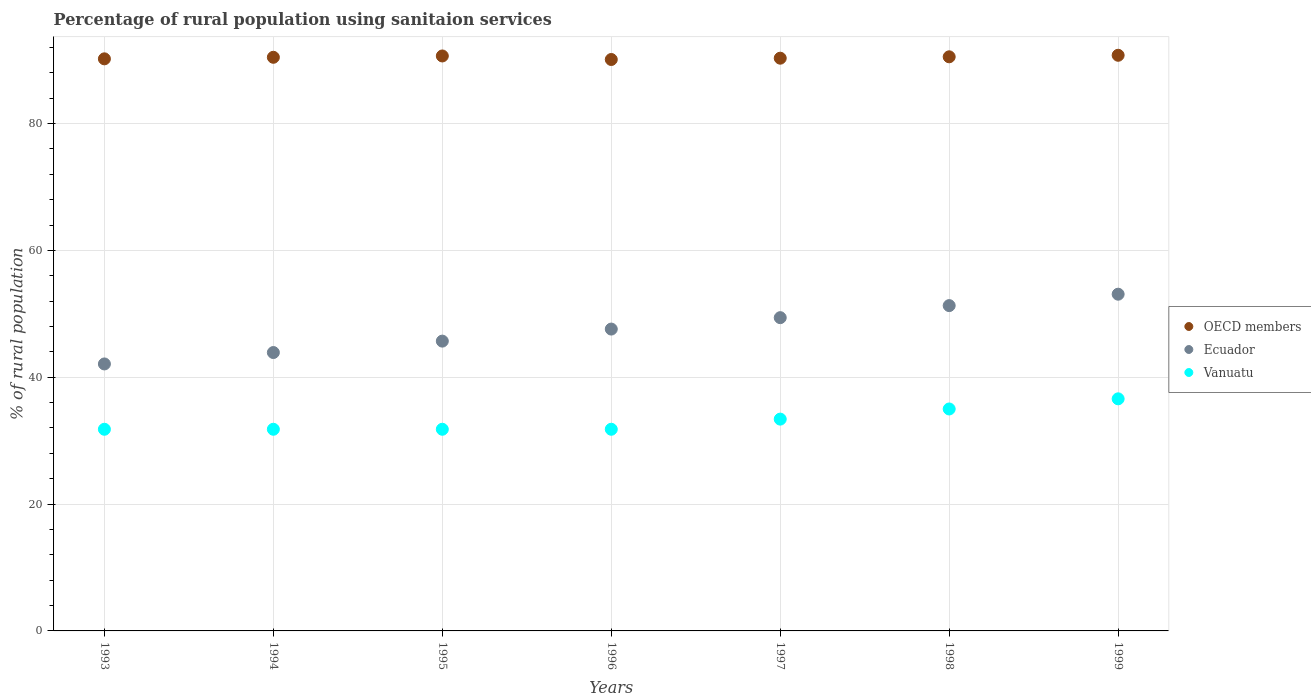How many different coloured dotlines are there?
Offer a very short reply. 3. Is the number of dotlines equal to the number of legend labels?
Give a very brief answer. Yes. What is the percentage of rural population using sanitaion services in Ecuador in 1999?
Offer a very short reply. 53.1. Across all years, what is the maximum percentage of rural population using sanitaion services in Vanuatu?
Your answer should be compact. 36.6. Across all years, what is the minimum percentage of rural population using sanitaion services in Vanuatu?
Your response must be concise. 31.8. In which year was the percentage of rural population using sanitaion services in Ecuador minimum?
Make the answer very short. 1993. What is the total percentage of rural population using sanitaion services in OECD members in the graph?
Offer a terse response. 633.08. What is the difference between the percentage of rural population using sanitaion services in OECD members in 1993 and that in 1999?
Your response must be concise. -0.56. What is the difference between the percentage of rural population using sanitaion services in Vanuatu in 1993 and the percentage of rural population using sanitaion services in Ecuador in 1997?
Ensure brevity in your answer.  -17.6. What is the average percentage of rural population using sanitaion services in Vanuatu per year?
Your answer should be very brief. 33.17. In the year 1998, what is the difference between the percentage of rural population using sanitaion services in Vanuatu and percentage of rural population using sanitaion services in Ecuador?
Your answer should be very brief. -16.3. In how many years, is the percentage of rural population using sanitaion services in OECD members greater than 80 %?
Ensure brevity in your answer.  7. Is the difference between the percentage of rural population using sanitaion services in Vanuatu in 1994 and 1999 greater than the difference between the percentage of rural population using sanitaion services in Ecuador in 1994 and 1999?
Keep it short and to the point. Yes. What is the difference between the highest and the second highest percentage of rural population using sanitaion services in Vanuatu?
Keep it short and to the point. 1.6. What is the difference between the highest and the lowest percentage of rural population using sanitaion services in OECD members?
Your answer should be very brief. 0.67. Is the sum of the percentage of rural population using sanitaion services in Ecuador in 1993 and 1996 greater than the maximum percentage of rural population using sanitaion services in OECD members across all years?
Your answer should be compact. No. Does the percentage of rural population using sanitaion services in Vanuatu monotonically increase over the years?
Provide a succinct answer. No. Is the percentage of rural population using sanitaion services in OECD members strictly greater than the percentage of rural population using sanitaion services in Ecuador over the years?
Your answer should be very brief. Yes. How many dotlines are there?
Your answer should be very brief. 3. What is the difference between two consecutive major ticks on the Y-axis?
Give a very brief answer. 20. Does the graph contain grids?
Make the answer very short. Yes. How many legend labels are there?
Your response must be concise. 3. What is the title of the graph?
Offer a very short reply. Percentage of rural population using sanitaion services. Does "Azerbaijan" appear as one of the legend labels in the graph?
Give a very brief answer. No. What is the label or title of the X-axis?
Your response must be concise. Years. What is the label or title of the Y-axis?
Offer a very short reply. % of rural population. What is the % of rural population in OECD members in 1993?
Offer a very short reply. 90.21. What is the % of rural population in Ecuador in 1993?
Offer a terse response. 42.1. What is the % of rural population in Vanuatu in 1993?
Provide a short and direct response. 31.8. What is the % of rural population in OECD members in 1994?
Your response must be concise. 90.46. What is the % of rural population of Ecuador in 1994?
Your response must be concise. 43.9. What is the % of rural population of Vanuatu in 1994?
Your answer should be compact. 31.8. What is the % of rural population in OECD members in 1995?
Provide a short and direct response. 90.67. What is the % of rural population of Ecuador in 1995?
Your response must be concise. 45.7. What is the % of rural population of Vanuatu in 1995?
Give a very brief answer. 31.8. What is the % of rural population of OECD members in 1996?
Ensure brevity in your answer.  90.11. What is the % of rural population in Ecuador in 1996?
Ensure brevity in your answer.  47.6. What is the % of rural population in Vanuatu in 1996?
Keep it short and to the point. 31.8. What is the % of rural population of OECD members in 1997?
Ensure brevity in your answer.  90.32. What is the % of rural population of Ecuador in 1997?
Make the answer very short. 49.4. What is the % of rural population in Vanuatu in 1997?
Your answer should be compact. 33.4. What is the % of rural population in OECD members in 1998?
Offer a terse response. 90.53. What is the % of rural population of Ecuador in 1998?
Provide a short and direct response. 51.3. What is the % of rural population of OECD members in 1999?
Keep it short and to the point. 90.78. What is the % of rural population of Ecuador in 1999?
Your answer should be compact. 53.1. What is the % of rural population in Vanuatu in 1999?
Your response must be concise. 36.6. Across all years, what is the maximum % of rural population of OECD members?
Provide a short and direct response. 90.78. Across all years, what is the maximum % of rural population in Ecuador?
Your answer should be very brief. 53.1. Across all years, what is the maximum % of rural population of Vanuatu?
Your response must be concise. 36.6. Across all years, what is the minimum % of rural population in OECD members?
Make the answer very short. 90.11. Across all years, what is the minimum % of rural population in Ecuador?
Ensure brevity in your answer.  42.1. Across all years, what is the minimum % of rural population in Vanuatu?
Provide a succinct answer. 31.8. What is the total % of rural population of OECD members in the graph?
Your answer should be compact. 633.08. What is the total % of rural population in Ecuador in the graph?
Provide a short and direct response. 333.1. What is the total % of rural population in Vanuatu in the graph?
Offer a very short reply. 232.2. What is the difference between the % of rural population of OECD members in 1993 and that in 1994?
Your answer should be compact. -0.24. What is the difference between the % of rural population in Ecuador in 1993 and that in 1994?
Give a very brief answer. -1.8. What is the difference between the % of rural population of OECD members in 1993 and that in 1995?
Offer a very short reply. -0.45. What is the difference between the % of rural population in OECD members in 1993 and that in 1996?
Your response must be concise. 0.1. What is the difference between the % of rural population of Vanuatu in 1993 and that in 1996?
Provide a short and direct response. 0. What is the difference between the % of rural population in OECD members in 1993 and that in 1997?
Make the answer very short. -0.1. What is the difference between the % of rural population in Ecuador in 1993 and that in 1997?
Offer a very short reply. -7.3. What is the difference between the % of rural population of OECD members in 1993 and that in 1998?
Your answer should be compact. -0.32. What is the difference between the % of rural population of Vanuatu in 1993 and that in 1998?
Your answer should be very brief. -3.2. What is the difference between the % of rural population in OECD members in 1993 and that in 1999?
Keep it short and to the point. -0.56. What is the difference between the % of rural population in Ecuador in 1993 and that in 1999?
Your answer should be compact. -11. What is the difference between the % of rural population in Vanuatu in 1993 and that in 1999?
Offer a very short reply. -4.8. What is the difference between the % of rural population of OECD members in 1994 and that in 1995?
Provide a succinct answer. -0.21. What is the difference between the % of rural population of Vanuatu in 1994 and that in 1995?
Provide a succinct answer. 0. What is the difference between the % of rural population in OECD members in 1994 and that in 1996?
Make the answer very short. 0.35. What is the difference between the % of rural population in Ecuador in 1994 and that in 1996?
Your answer should be very brief. -3.7. What is the difference between the % of rural population in Vanuatu in 1994 and that in 1996?
Offer a terse response. 0. What is the difference between the % of rural population of OECD members in 1994 and that in 1997?
Keep it short and to the point. 0.14. What is the difference between the % of rural population of Ecuador in 1994 and that in 1997?
Your answer should be compact. -5.5. What is the difference between the % of rural population of OECD members in 1994 and that in 1998?
Provide a succinct answer. -0.08. What is the difference between the % of rural population of Vanuatu in 1994 and that in 1998?
Give a very brief answer. -3.2. What is the difference between the % of rural population in OECD members in 1994 and that in 1999?
Provide a short and direct response. -0.32. What is the difference between the % of rural population of Ecuador in 1994 and that in 1999?
Provide a short and direct response. -9.2. What is the difference between the % of rural population in Vanuatu in 1994 and that in 1999?
Make the answer very short. -4.8. What is the difference between the % of rural population of OECD members in 1995 and that in 1996?
Provide a succinct answer. 0.56. What is the difference between the % of rural population in Vanuatu in 1995 and that in 1996?
Offer a terse response. 0. What is the difference between the % of rural population of OECD members in 1995 and that in 1997?
Offer a very short reply. 0.35. What is the difference between the % of rural population of OECD members in 1995 and that in 1998?
Give a very brief answer. 0.13. What is the difference between the % of rural population in Vanuatu in 1995 and that in 1998?
Provide a short and direct response. -3.2. What is the difference between the % of rural population of OECD members in 1995 and that in 1999?
Provide a succinct answer. -0.11. What is the difference between the % of rural population of OECD members in 1996 and that in 1997?
Your answer should be very brief. -0.21. What is the difference between the % of rural population of Ecuador in 1996 and that in 1997?
Your answer should be compact. -1.8. What is the difference between the % of rural population of Vanuatu in 1996 and that in 1997?
Offer a very short reply. -1.6. What is the difference between the % of rural population in OECD members in 1996 and that in 1998?
Offer a terse response. -0.42. What is the difference between the % of rural population of Ecuador in 1996 and that in 1998?
Give a very brief answer. -3.7. What is the difference between the % of rural population of Vanuatu in 1996 and that in 1998?
Offer a terse response. -3.2. What is the difference between the % of rural population of OECD members in 1996 and that in 1999?
Ensure brevity in your answer.  -0.67. What is the difference between the % of rural population of Vanuatu in 1996 and that in 1999?
Make the answer very short. -4.8. What is the difference between the % of rural population in OECD members in 1997 and that in 1998?
Offer a very short reply. -0.22. What is the difference between the % of rural population of Vanuatu in 1997 and that in 1998?
Offer a very short reply. -1.6. What is the difference between the % of rural population in OECD members in 1997 and that in 1999?
Ensure brevity in your answer.  -0.46. What is the difference between the % of rural population of Ecuador in 1997 and that in 1999?
Ensure brevity in your answer.  -3.7. What is the difference between the % of rural population in OECD members in 1998 and that in 1999?
Provide a short and direct response. -0.24. What is the difference between the % of rural population of OECD members in 1993 and the % of rural population of Ecuador in 1994?
Ensure brevity in your answer.  46.31. What is the difference between the % of rural population of OECD members in 1993 and the % of rural population of Vanuatu in 1994?
Ensure brevity in your answer.  58.41. What is the difference between the % of rural population of OECD members in 1993 and the % of rural population of Ecuador in 1995?
Provide a short and direct response. 44.51. What is the difference between the % of rural population in OECD members in 1993 and the % of rural population in Vanuatu in 1995?
Offer a very short reply. 58.41. What is the difference between the % of rural population of OECD members in 1993 and the % of rural population of Ecuador in 1996?
Make the answer very short. 42.61. What is the difference between the % of rural population of OECD members in 1993 and the % of rural population of Vanuatu in 1996?
Give a very brief answer. 58.41. What is the difference between the % of rural population in Ecuador in 1993 and the % of rural population in Vanuatu in 1996?
Offer a very short reply. 10.3. What is the difference between the % of rural population in OECD members in 1993 and the % of rural population in Ecuador in 1997?
Your answer should be compact. 40.81. What is the difference between the % of rural population in OECD members in 1993 and the % of rural population in Vanuatu in 1997?
Keep it short and to the point. 56.81. What is the difference between the % of rural population in OECD members in 1993 and the % of rural population in Ecuador in 1998?
Ensure brevity in your answer.  38.91. What is the difference between the % of rural population of OECD members in 1993 and the % of rural population of Vanuatu in 1998?
Your response must be concise. 55.21. What is the difference between the % of rural population of Ecuador in 1993 and the % of rural population of Vanuatu in 1998?
Keep it short and to the point. 7.1. What is the difference between the % of rural population in OECD members in 1993 and the % of rural population in Ecuador in 1999?
Your response must be concise. 37.11. What is the difference between the % of rural population of OECD members in 1993 and the % of rural population of Vanuatu in 1999?
Your answer should be very brief. 53.61. What is the difference between the % of rural population of OECD members in 1994 and the % of rural population of Ecuador in 1995?
Offer a terse response. 44.76. What is the difference between the % of rural population of OECD members in 1994 and the % of rural population of Vanuatu in 1995?
Your answer should be very brief. 58.66. What is the difference between the % of rural population of Ecuador in 1994 and the % of rural population of Vanuatu in 1995?
Give a very brief answer. 12.1. What is the difference between the % of rural population of OECD members in 1994 and the % of rural population of Ecuador in 1996?
Ensure brevity in your answer.  42.86. What is the difference between the % of rural population of OECD members in 1994 and the % of rural population of Vanuatu in 1996?
Offer a very short reply. 58.66. What is the difference between the % of rural population of Ecuador in 1994 and the % of rural population of Vanuatu in 1996?
Provide a short and direct response. 12.1. What is the difference between the % of rural population in OECD members in 1994 and the % of rural population in Ecuador in 1997?
Your answer should be compact. 41.06. What is the difference between the % of rural population in OECD members in 1994 and the % of rural population in Vanuatu in 1997?
Give a very brief answer. 57.06. What is the difference between the % of rural population of Ecuador in 1994 and the % of rural population of Vanuatu in 1997?
Your response must be concise. 10.5. What is the difference between the % of rural population of OECD members in 1994 and the % of rural population of Ecuador in 1998?
Make the answer very short. 39.16. What is the difference between the % of rural population of OECD members in 1994 and the % of rural population of Vanuatu in 1998?
Provide a succinct answer. 55.46. What is the difference between the % of rural population in OECD members in 1994 and the % of rural population in Ecuador in 1999?
Provide a succinct answer. 37.36. What is the difference between the % of rural population of OECD members in 1994 and the % of rural population of Vanuatu in 1999?
Make the answer very short. 53.86. What is the difference between the % of rural population of Ecuador in 1994 and the % of rural population of Vanuatu in 1999?
Keep it short and to the point. 7.3. What is the difference between the % of rural population in OECD members in 1995 and the % of rural population in Ecuador in 1996?
Make the answer very short. 43.07. What is the difference between the % of rural population of OECD members in 1995 and the % of rural population of Vanuatu in 1996?
Give a very brief answer. 58.87. What is the difference between the % of rural population of Ecuador in 1995 and the % of rural population of Vanuatu in 1996?
Provide a succinct answer. 13.9. What is the difference between the % of rural population of OECD members in 1995 and the % of rural population of Ecuador in 1997?
Make the answer very short. 41.27. What is the difference between the % of rural population in OECD members in 1995 and the % of rural population in Vanuatu in 1997?
Offer a terse response. 57.27. What is the difference between the % of rural population of OECD members in 1995 and the % of rural population of Ecuador in 1998?
Offer a terse response. 39.37. What is the difference between the % of rural population in OECD members in 1995 and the % of rural population in Vanuatu in 1998?
Your response must be concise. 55.67. What is the difference between the % of rural population in Ecuador in 1995 and the % of rural population in Vanuatu in 1998?
Your answer should be very brief. 10.7. What is the difference between the % of rural population in OECD members in 1995 and the % of rural population in Ecuador in 1999?
Make the answer very short. 37.57. What is the difference between the % of rural population of OECD members in 1995 and the % of rural population of Vanuatu in 1999?
Provide a short and direct response. 54.07. What is the difference between the % of rural population in OECD members in 1996 and the % of rural population in Ecuador in 1997?
Offer a very short reply. 40.71. What is the difference between the % of rural population of OECD members in 1996 and the % of rural population of Vanuatu in 1997?
Your answer should be very brief. 56.71. What is the difference between the % of rural population in Ecuador in 1996 and the % of rural population in Vanuatu in 1997?
Give a very brief answer. 14.2. What is the difference between the % of rural population of OECD members in 1996 and the % of rural population of Ecuador in 1998?
Keep it short and to the point. 38.81. What is the difference between the % of rural population in OECD members in 1996 and the % of rural population in Vanuatu in 1998?
Provide a succinct answer. 55.11. What is the difference between the % of rural population of Ecuador in 1996 and the % of rural population of Vanuatu in 1998?
Provide a succinct answer. 12.6. What is the difference between the % of rural population of OECD members in 1996 and the % of rural population of Ecuador in 1999?
Your answer should be compact. 37.01. What is the difference between the % of rural population of OECD members in 1996 and the % of rural population of Vanuatu in 1999?
Provide a short and direct response. 53.51. What is the difference between the % of rural population in OECD members in 1997 and the % of rural population in Ecuador in 1998?
Provide a short and direct response. 39.02. What is the difference between the % of rural population of OECD members in 1997 and the % of rural population of Vanuatu in 1998?
Give a very brief answer. 55.32. What is the difference between the % of rural population of OECD members in 1997 and the % of rural population of Ecuador in 1999?
Your answer should be compact. 37.22. What is the difference between the % of rural population of OECD members in 1997 and the % of rural population of Vanuatu in 1999?
Provide a succinct answer. 53.72. What is the difference between the % of rural population of Ecuador in 1997 and the % of rural population of Vanuatu in 1999?
Keep it short and to the point. 12.8. What is the difference between the % of rural population of OECD members in 1998 and the % of rural population of Ecuador in 1999?
Offer a terse response. 37.43. What is the difference between the % of rural population in OECD members in 1998 and the % of rural population in Vanuatu in 1999?
Ensure brevity in your answer.  53.93. What is the average % of rural population in OECD members per year?
Your answer should be very brief. 90.44. What is the average % of rural population of Ecuador per year?
Provide a short and direct response. 47.59. What is the average % of rural population in Vanuatu per year?
Offer a terse response. 33.17. In the year 1993, what is the difference between the % of rural population of OECD members and % of rural population of Ecuador?
Provide a succinct answer. 48.11. In the year 1993, what is the difference between the % of rural population of OECD members and % of rural population of Vanuatu?
Your answer should be very brief. 58.41. In the year 1993, what is the difference between the % of rural population of Ecuador and % of rural population of Vanuatu?
Offer a very short reply. 10.3. In the year 1994, what is the difference between the % of rural population of OECD members and % of rural population of Ecuador?
Give a very brief answer. 46.56. In the year 1994, what is the difference between the % of rural population of OECD members and % of rural population of Vanuatu?
Offer a terse response. 58.66. In the year 1995, what is the difference between the % of rural population in OECD members and % of rural population in Ecuador?
Make the answer very short. 44.97. In the year 1995, what is the difference between the % of rural population in OECD members and % of rural population in Vanuatu?
Give a very brief answer. 58.87. In the year 1996, what is the difference between the % of rural population of OECD members and % of rural population of Ecuador?
Keep it short and to the point. 42.51. In the year 1996, what is the difference between the % of rural population of OECD members and % of rural population of Vanuatu?
Give a very brief answer. 58.31. In the year 1996, what is the difference between the % of rural population in Ecuador and % of rural population in Vanuatu?
Keep it short and to the point. 15.8. In the year 1997, what is the difference between the % of rural population of OECD members and % of rural population of Ecuador?
Your answer should be very brief. 40.92. In the year 1997, what is the difference between the % of rural population in OECD members and % of rural population in Vanuatu?
Your answer should be very brief. 56.92. In the year 1997, what is the difference between the % of rural population in Ecuador and % of rural population in Vanuatu?
Give a very brief answer. 16. In the year 1998, what is the difference between the % of rural population in OECD members and % of rural population in Ecuador?
Your answer should be very brief. 39.23. In the year 1998, what is the difference between the % of rural population of OECD members and % of rural population of Vanuatu?
Keep it short and to the point. 55.53. In the year 1998, what is the difference between the % of rural population in Ecuador and % of rural population in Vanuatu?
Make the answer very short. 16.3. In the year 1999, what is the difference between the % of rural population of OECD members and % of rural population of Ecuador?
Give a very brief answer. 37.68. In the year 1999, what is the difference between the % of rural population in OECD members and % of rural population in Vanuatu?
Give a very brief answer. 54.18. What is the ratio of the % of rural population of OECD members in 1993 to that in 1994?
Keep it short and to the point. 1. What is the ratio of the % of rural population in Ecuador in 1993 to that in 1994?
Offer a very short reply. 0.96. What is the ratio of the % of rural population in OECD members in 1993 to that in 1995?
Provide a short and direct response. 0.99. What is the ratio of the % of rural population in Ecuador in 1993 to that in 1995?
Give a very brief answer. 0.92. What is the ratio of the % of rural population of Vanuatu in 1993 to that in 1995?
Give a very brief answer. 1. What is the ratio of the % of rural population of Ecuador in 1993 to that in 1996?
Offer a terse response. 0.88. What is the ratio of the % of rural population in OECD members in 1993 to that in 1997?
Ensure brevity in your answer.  1. What is the ratio of the % of rural population in Ecuador in 1993 to that in 1997?
Give a very brief answer. 0.85. What is the ratio of the % of rural population in Vanuatu in 1993 to that in 1997?
Offer a terse response. 0.95. What is the ratio of the % of rural population of Ecuador in 1993 to that in 1998?
Make the answer very short. 0.82. What is the ratio of the % of rural population in Vanuatu in 1993 to that in 1998?
Give a very brief answer. 0.91. What is the ratio of the % of rural population in Ecuador in 1993 to that in 1999?
Your answer should be compact. 0.79. What is the ratio of the % of rural population in Vanuatu in 1993 to that in 1999?
Your response must be concise. 0.87. What is the ratio of the % of rural population of Ecuador in 1994 to that in 1995?
Your answer should be very brief. 0.96. What is the ratio of the % of rural population of OECD members in 1994 to that in 1996?
Give a very brief answer. 1. What is the ratio of the % of rural population in Ecuador in 1994 to that in 1996?
Make the answer very short. 0.92. What is the ratio of the % of rural population of Vanuatu in 1994 to that in 1996?
Your answer should be very brief. 1. What is the ratio of the % of rural population of Ecuador in 1994 to that in 1997?
Offer a terse response. 0.89. What is the ratio of the % of rural population in Vanuatu in 1994 to that in 1997?
Give a very brief answer. 0.95. What is the ratio of the % of rural population in Ecuador in 1994 to that in 1998?
Keep it short and to the point. 0.86. What is the ratio of the % of rural population of Vanuatu in 1994 to that in 1998?
Your response must be concise. 0.91. What is the ratio of the % of rural population of OECD members in 1994 to that in 1999?
Your response must be concise. 1. What is the ratio of the % of rural population in Ecuador in 1994 to that in 1999?
Your answer should be very brief. 0.83. What is the ratio of the % of rural population of Vanuatu in 1994 to that in 1999?
Provide a short and direct response. 0.87. What is the ratio of the % of rural population of Ecuador in 1995 to that in 1996?
Your answer should be compact. 0.96. What is the ratio of the % of rural population of Vanuatu in 1995 to that in 1996?
Your answer should be compact. 1. What is the ratio of the % of rural population of Ecuador in 1995 to that in 1997?
Provide a short and direct response. 0.93. What is the ratio of the % of rural population of Vanuatu in 1995 to that in 1997?
Your answer should be very brief. 0.95. What is the ratio of the % of rural population of OECD members in 1995 to that in 1998?
Your answer should be compact. 1. What is the ratio of the % of rural population in Ecuador in 1995 to that in 1998?
Your response must be concise. 0.89. What is the ratio of the % of rural population in Vanuatu in 1995 to that in 1998?
Your response must be concise. 0.91. What is the ratio of the % of rural population in OECD members in 1995 to that in 1999?
Provide a short and direct response. 1. What is the ratio of the % of rural population of Ecuador in 1995 to that in 1999?
Ensure brevity in your answer.  0.86. What is the ratio of the % of rural population in Vanuatu in 1995 to that in 1999?
Ensure brevity in your answer.  0.87. What is the ratio of the % of rural population of Ecuador in 1996 to that in 1997?
Provide a short and direct response. 0.96. What is the ratio of the % of rural population of Vanuatu in 1996 to that in 1997?
Offer a terse response. 0.95. What is the ratio of the % of rural population of OECD members in 1996 to that in 1998?
Your answer should be compact. 1. What is the ratio of the % of rural population in Ecuador in 1996 to that in 1998?
Ensure brevity in your answer.  0.93. What is the ratio of the % of rural population of Vanuatu in 1996 to that in 1998?
Make the answer very short. 0.91. What is the ratio of the % of rural population of OECD members in 1996 to that in 1999?
Give a very brief answer. 0.99. What is the ratio of the % of rural population of Ecuador in 1996 to that in 1999?
Make the answer very short. 0.9. What is the ratio of the % of rural population in Vanuatu in 1996 to that in 1999?
Your answer should be very brief. 0.87. What is the ratio of the % of rural population in Vanuatu in 1997 to that in 1998?
Ensure brevity in your answer.  0.95. What is the ratio of the % of rural population in OECD members in 1997 to that in 1999?
Your answer should be compact. 0.99. What is the ratio of the % of rural population in Ecuador in 1997 to that in 1999?
Keep it short and to the point. 0.93. What is the ratio of the % of rural population in Vanuatu in 1997 to that in 1999?
Offer a very short reply. 0.91. What is the ratio of the % of rural population of Ecuador in 1998 to that in 1999?
Provide a short and direct response. 0.97. What is the ratio of the % of rural population in Vanuatu in 1998 to that in 1999?
Ensure brevity in your answer.  0.96. What is the difference between the highest and the second highest % of rural population of OECD members?
Offer a terse response. 0.11. What is the difference between the highest and the second highest % of rural population in Vanuatu?
Your answer should be very brief. 1.6. What is the difference between the highest and the lowest % of rural population in OECD members?
Ensure brevity in your answer.  0.67. What is the difference between the highest and the lowest % of rural population in Ecuador?
Offer a terse response. 11. 